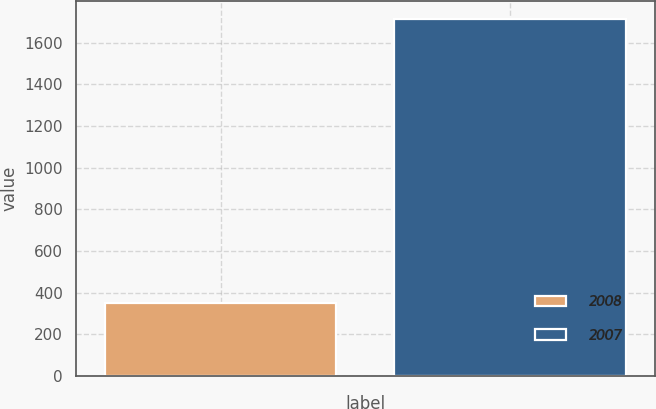Convert chart to OTSL. <chart><loc_0><loc_0><loc_500><loc_500><bar_chart><fcel>2008<fcel>2007<nl><fcel>352<fcel>1712<nl></chart> 